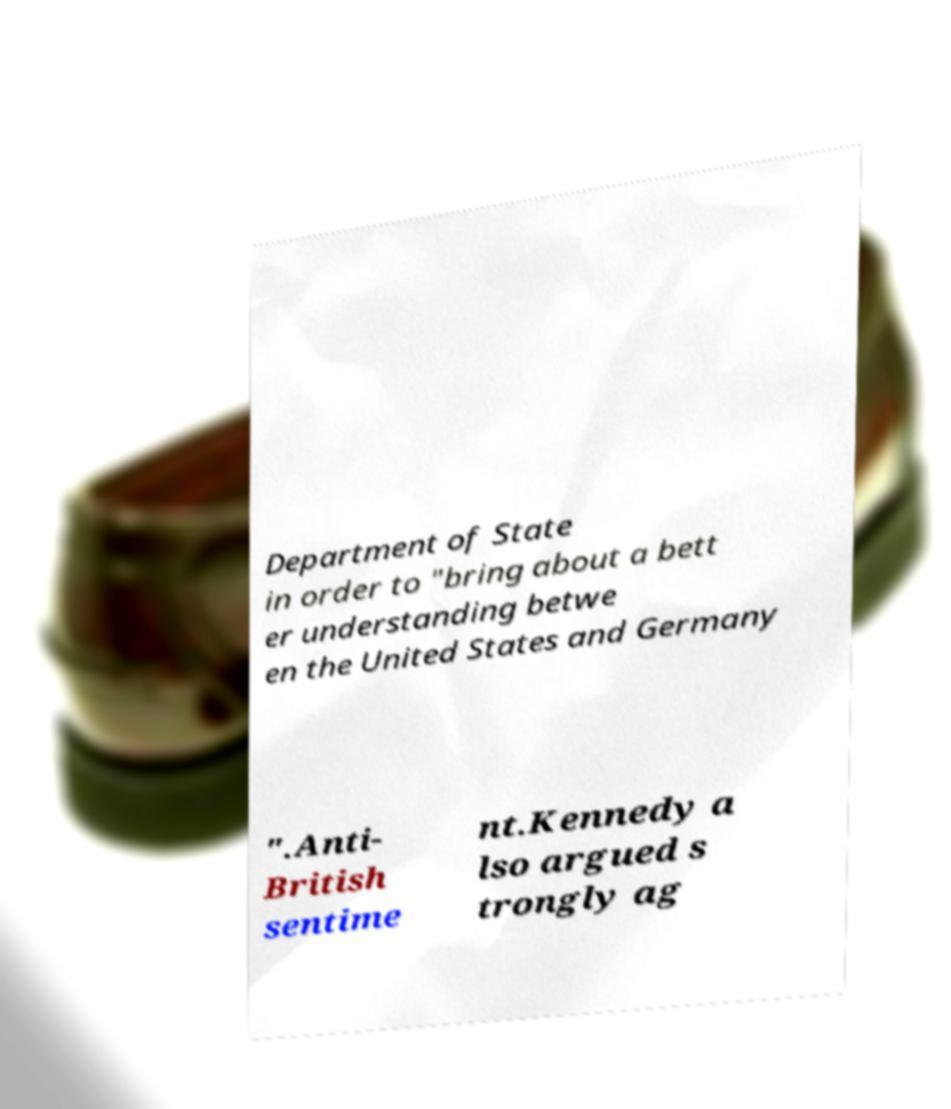Please read and relay the text visible in this image. What does it say? Department of State in order to "bring about a bett er understanding betwe en the United States and Germany ".Anti- British sentime nt.Kennedy a lso argued s trongly ag 